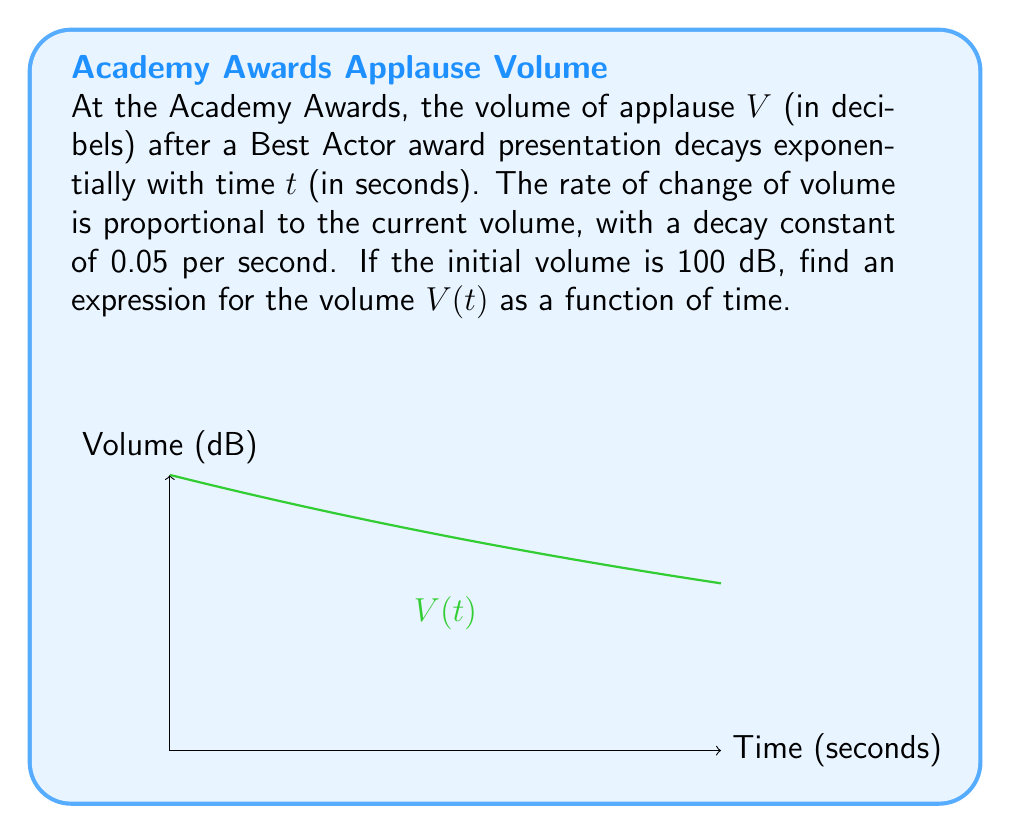What is the answer to this math problem? Let's approach this step-by-step:

1) The rate of change of volume is proportional to the current volume. This can be expressed as:

   $$\frac{dV}{dt} = -kV$$

   where $k$ is the decay constant, and the negative sign indicates decay.

2) We're given that $k = 0.05$ per second. Substituting this:

   $$\frac{dV}{dt} = -0.05V$$

3) This is a separable differential equation. Let's separate the variables:

   $$\frac{dV}{V} = -0.05dt$$

4) Integrate both sides:

   $$\int \frac{dV}{V} = \int -0.05dt$$

5) This gives us:

   $$\ln|V| = -0.05t + C$$

   where $C$ is the constant of integration.

6) Exponentiate both sides:

   $$V = e^{-0.05t + C} = e^C \cdot e^{-0.05t}$$

7) Let $A = e^C$. Then our general solution is:

   $$V(t) = Ae^{-0.05t}$$

8) To find $A$, we use the initial condition. At $t=0$, $V=100$:

   $$100 = Ae^{-0.05(0)} = A$$

9) Therefore, our specific solution is:

   $$V(t) = 100e^{-0.05t}$$

This equation describes the volume of applause as a function of time after the award presentation.
Answer: $V(t) = 100e^{-0.05t}$ 